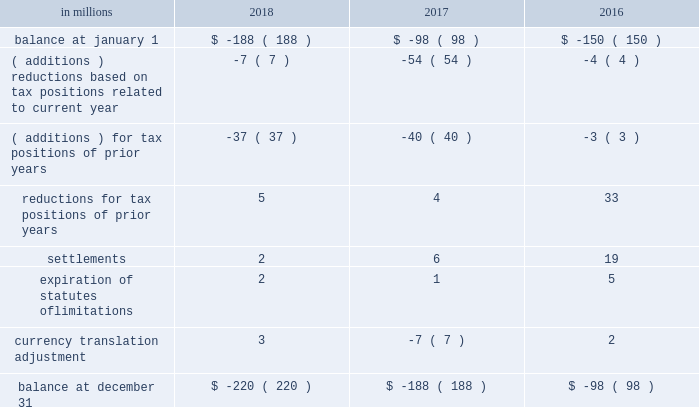( a ) the net change in the total valuation allowance for the years ended december 31 , 2018 and 2017 was an increase of $ 12 million and an increase of $ 26 million , respectively .
Deferred income tax assets and liabilities are recorded in the accompanying consolidated balance sheet under the captions deferred charges and other assets and deferred income taxes .
There was a decrease in deferred income tax assets principally relating to the utilization of u.s .
Federal alternative minimum tax credits as permitted under tax reform .
Deferred tax liabilities increased primarily due to the tax deferral of the book gain recognized on the transfer of the north american consumer packaging business to a subsidiary of graphic packaging holding company .
Of the $ 1.5 billion of deferred tax liabilities for forestlands , related installment sales , and investment in subsidiary , $ 884 million is attributable to an investment in subsidiary and relates to a 2006 international paper installment sale of forestlands and $ 538 million is attributable to a 2007 temple-inland installment sale of forestlands ( see note 14 ) .
A reconciliation of the beginning and ending amount of unrecognized tax benefits for the years ended december 31 , 2018 , 2017 and 2016 is as follows: .
If the company were to prevail on the unrecognized tax benefits recorded , substantially all of the balances at december 31 , 2018 , 2017 and 2016 would benefit the effective tax rate .
The company accrues interest on unrecognized tax benefits as a component of interest expense .
Penalties , if incurred , are recognized as a component of income tax expense .
The company had approximately $ 21 million and $ 17 million accrued for the payment of estimated interest and penalties associated with unrecognized tax benefits at december 31 , 2018 and 2017 , respectively .
The major jurisdictions where the company files income tax returns are the united states , brazil , france , poland and russia .
Generally , tax years 2006 through 2017 remain open and subject to examination by the relevant tax authorities .
The company frequently faces challenges regarding the amount of taxes due .
These challenges include positions taken by the company related to the timing , nature , and amount of deductions and the allocation of income among various tax jurisdictions .
Pending audit settlements and the expiration of statute of limitations could reduce the uncertain tax positions by $ 30 million during the next twelve months .
The brazilian federal revenue service has challenged the deductibility of goodwill amortization generated in a 2007 acquisition by international paper do brasil ltda. , a wholly-owned subsidiary of the company .
The company received assessments for the tax years 2007-2015 totaling approximately $ 150 million in tax , and $ 380 million in interest and penalties as of december 31 , 2018 ( adjusted for variation in currency exchange rates ) .
After a previous favorable ruling challenging the basis for these assessments , we received an unfavorable decision in october 2018 from the brazilian administrative council of tax appeals .
The company intends to further appeal the matter in the brazilian federal courts in 2019 ; however , this tax litigation matter may take many years to resolve .
The company believes that it has appropriately evaluated the transaction underlying these assessments , and has concluded based on brazilian tax law , that its tax position would be sustained .
The company intends to vigorously defend its position against the current assessments and any similar assessments that may be issued for tax years subsequent to 2015 .
International paper uses the flow-through method to account for investment tax credits earned on eligible open-loop biomass facilities and combined heat and power system expenditures .
Under this method , the investment tax credits are recognized as a reduction to income tax expense in the year they are earned rather than a reduction in the asset basis .
The company recorded a tax benefit of $ 6 million during 2018 and recorded a tax benefit of $ 68 million during 2017 related to investment tax credits earned in tax years 2013-2017. .
What is the highest value of reductions for tax positions of prior years? 
Rationale: it is the maximum value .
Computations: table_max(reductions for tax positions of prior years, none)
Answer: 33.0. 